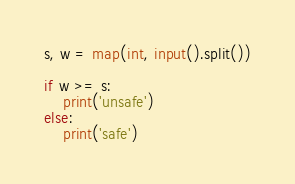Convert code to text. <code><loc_0><loc_0><loc_500><loc_500><_Python_>s, w = map(int, input().split())

if w >= s:
    print('unsafe')
else:
    print('safe')</code> 